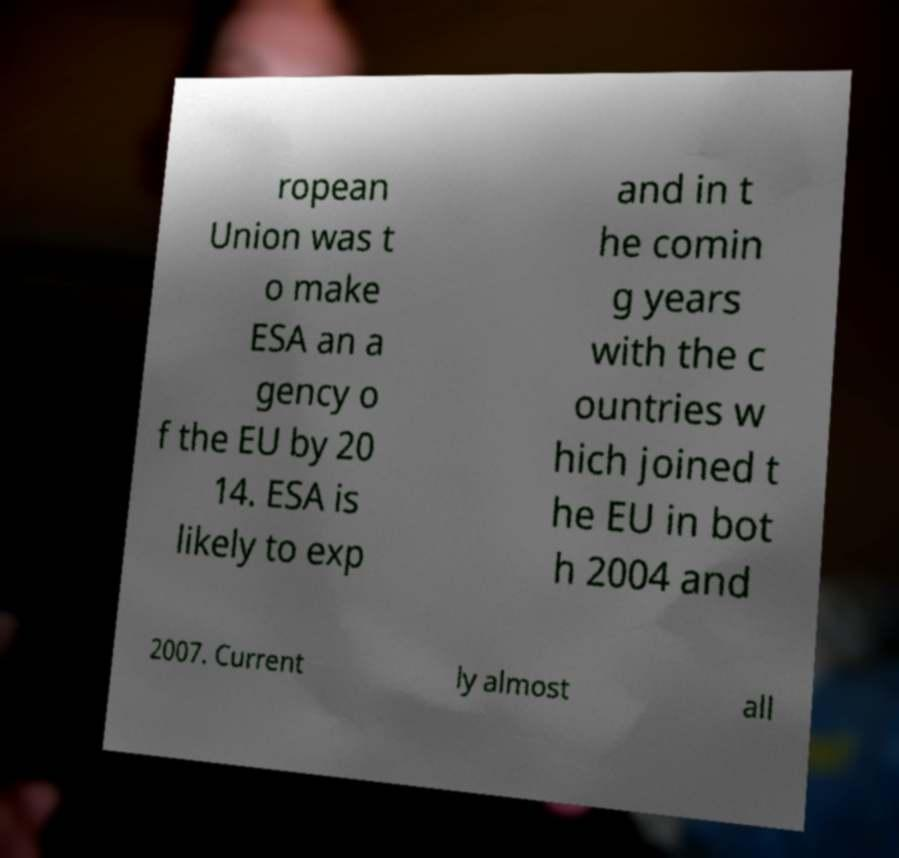Could you extract and type out the text from this image? ropean Union was t o make ESA an a gency o f the EU by 20 14. ESA is likely to exp and in t he comin g years with the c ountries w hich joined t he EU in bot h 2004 and 2007. Current ly almost all 